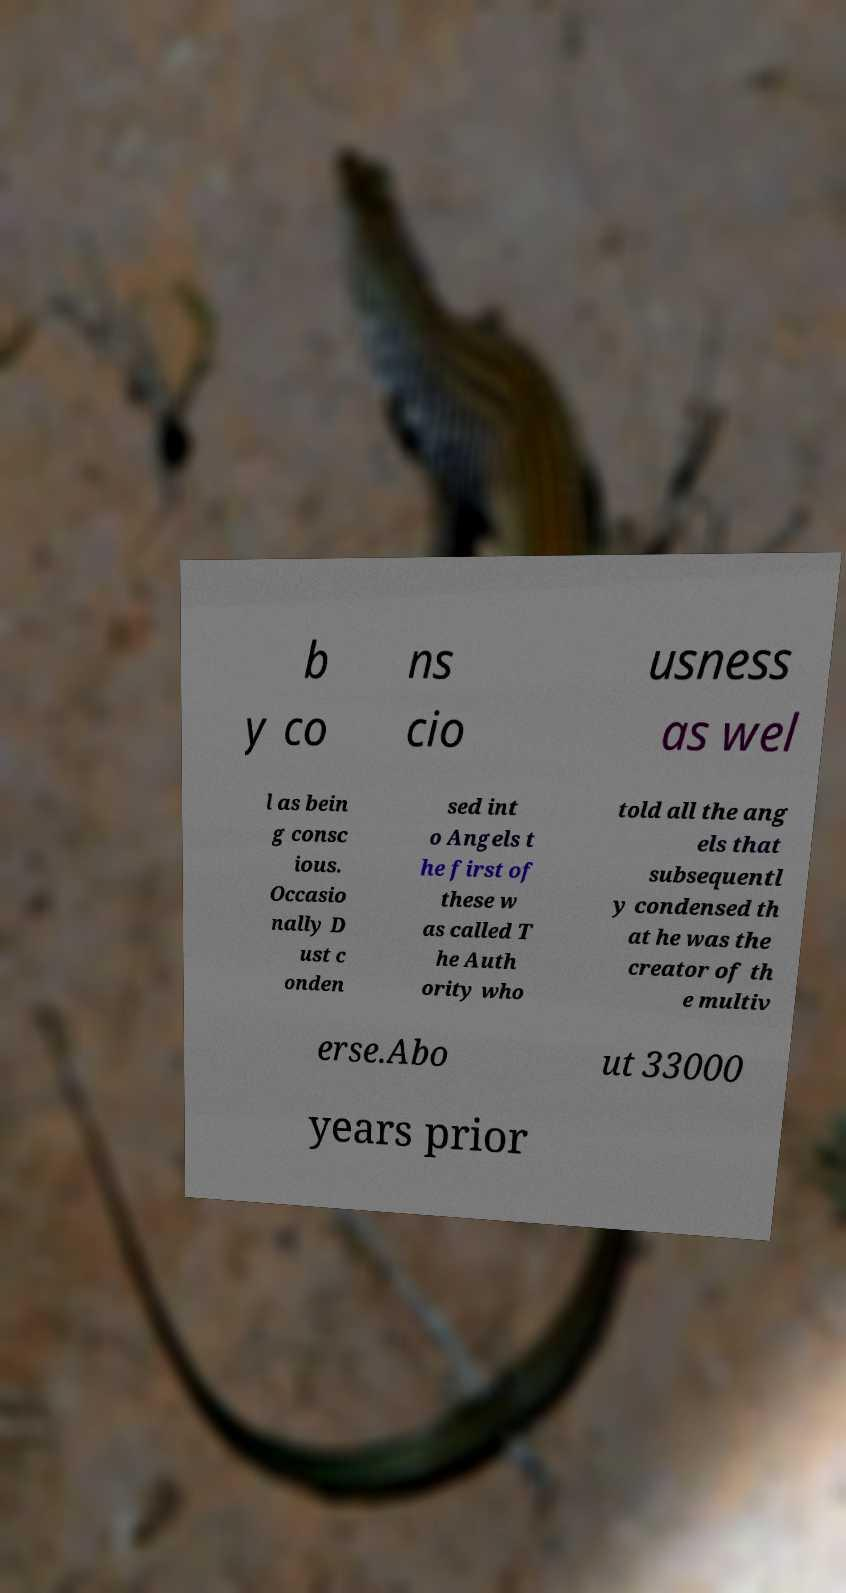Please identify and transcribe the text found in this image. b y co ns cio usness as wel l as bein g consc ious. Occasio nally D ust c onden sed int o Angels t he first of these w as called T he Auth ority who told all the ang els that subsequentl y condensed th at he was the creator of th e multiv erse.Abo ut 33000 years prior 